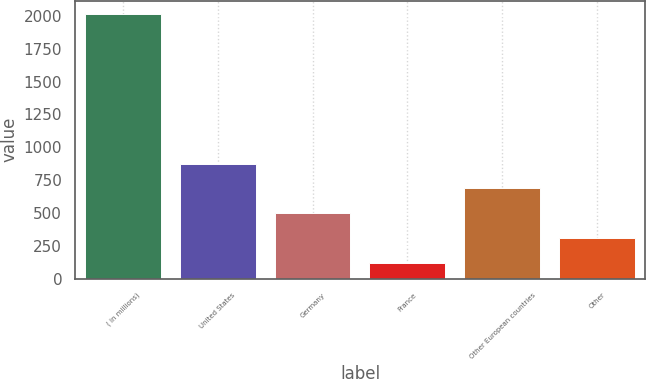Convert chart. <chart><loc_0><loc_0><loc_500><loc_500><bar_chart><fcel>( in millions)<fcel>United States<fcel>Germany<fcel>France<fcel>Other European countries<fcel>Other<nl><fcel>2016<fcel>876.18<fcel>496.24<fcel>116.3<fcel>686.21<fcel>306.27<nl></chart> 